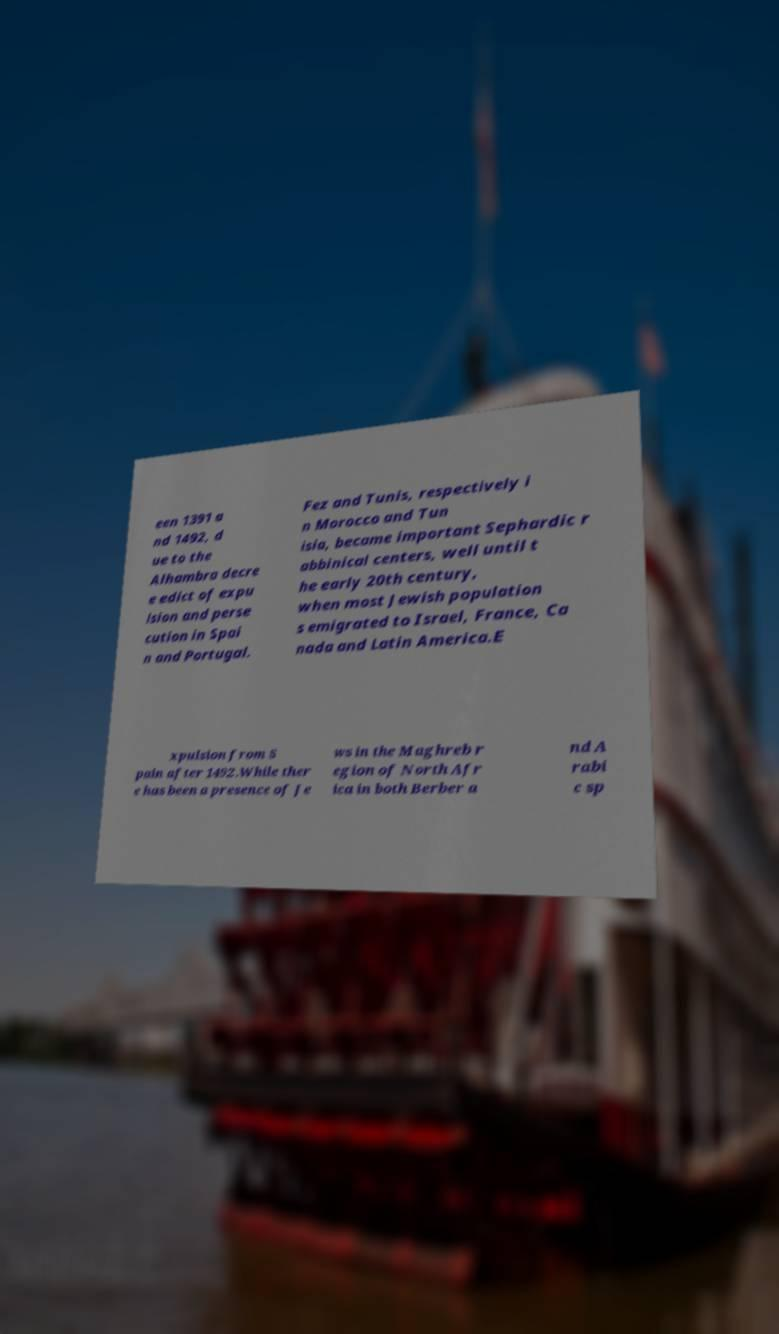Could you extract and type out the text from this image? een 1391 a nd 1492, d ue to the Alhambra decre e edict of expu lsion and perse cution in Spai n and Portugal. Fez and Tunis, respectively i n Morocco and Tun isia, became important Sephardic r abbinical centers, well until t he early 20th century, when most Jewish population s emigrated to Israel, France, Ca nada and Latin America.E xpulsion from S pain after 1492.While ther e has been a presence of Je ws in the Maghreb r egion of North Afr ica in both Berber a nd A rabi c sp 